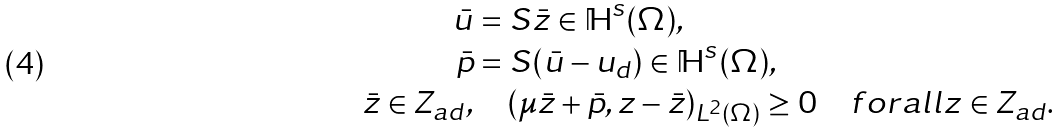Convert formula to latex. <formula><loc_0><loc_0><loc_500><loc_500>\bar { u } & = S \bar { z } \in \mathbb { H } ^ { s } ( \Omega ) , \\ \bar { p } & = S ( \bar { u } - u _ { d } ) \in \mathbb { H } ^ { s } ( \Omega ) , \\ \bar { z } \in Z _ { a d } , & \quad ( \mu \bar { z } + \bar { p } , z - \bar { z } ) _ { L ^ { 2 } ( \Omega ) } \geq 0 \quad f o r a l l z \in Z _ { a d } .</formula> 